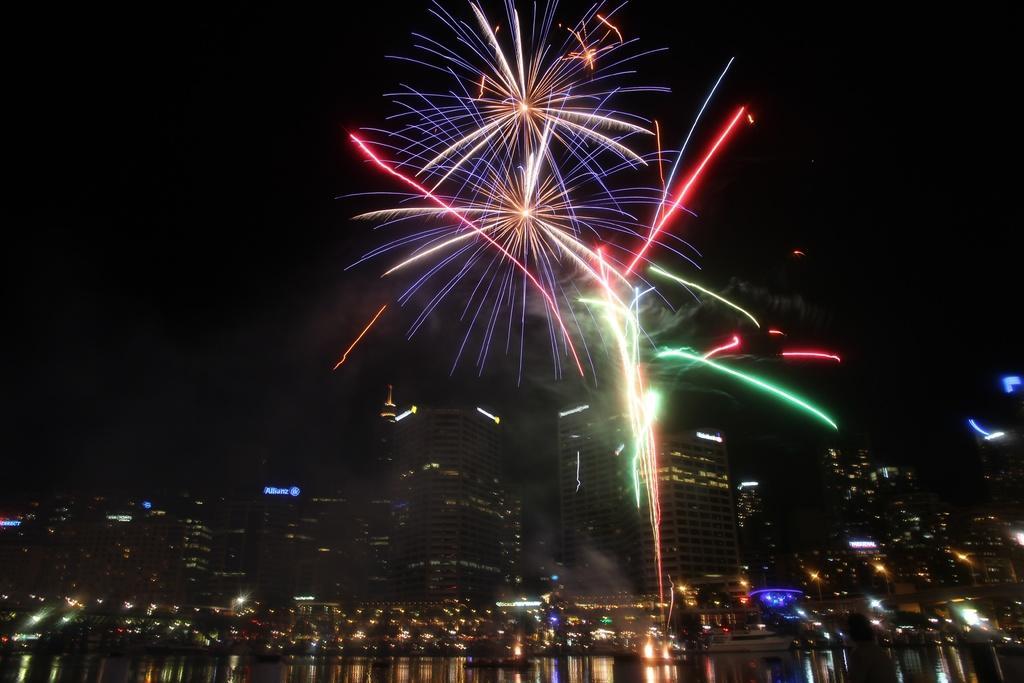Could you give a brief overview of what you see in this image? There is a water at the bottom of this image and there are some buildings in the background. There are some fireworks is in the sky. 